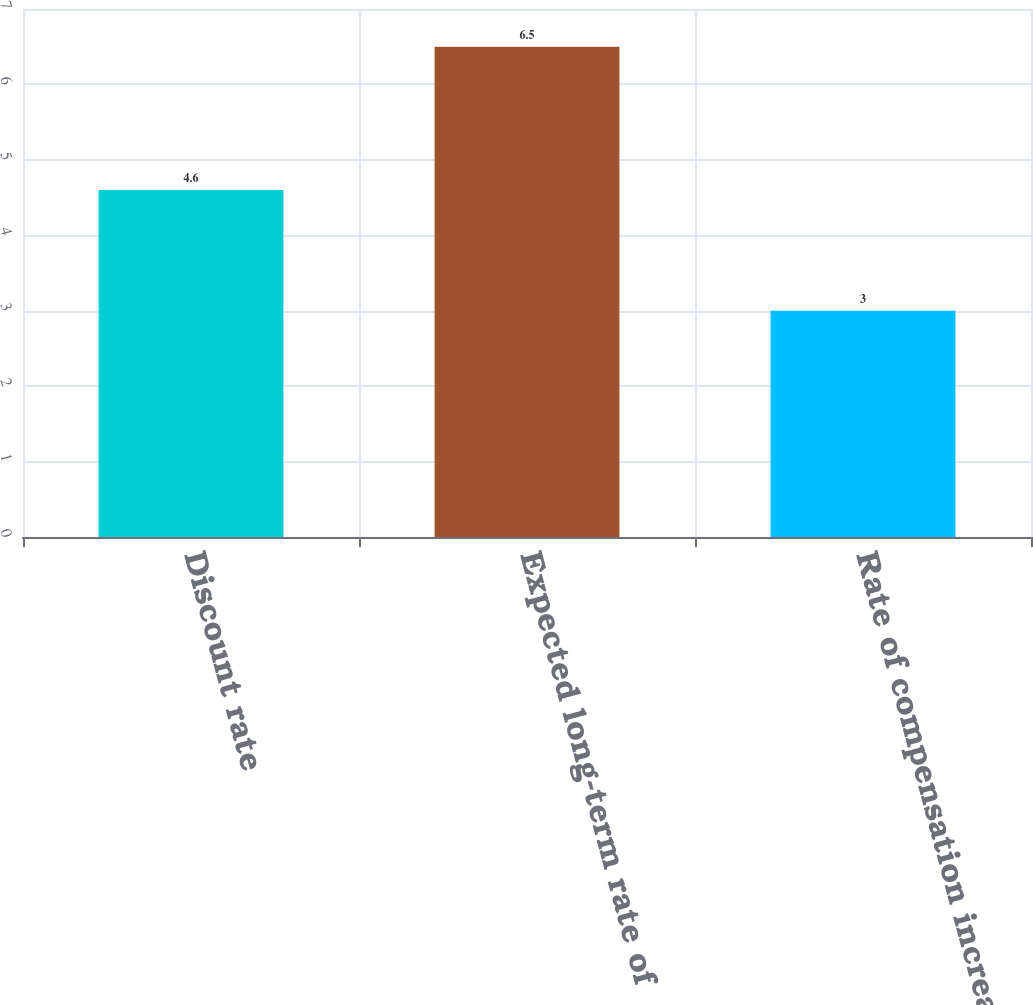<chart> <loc_0><loc_0><loc_500><loc_500><bar_chart><fcel>Discount rate<fcel>Expected long-term rate of<fcel>Rate of compensation increase<nl><fcel>4.6<fcel>6.5<fcel>3<nl></chart> 